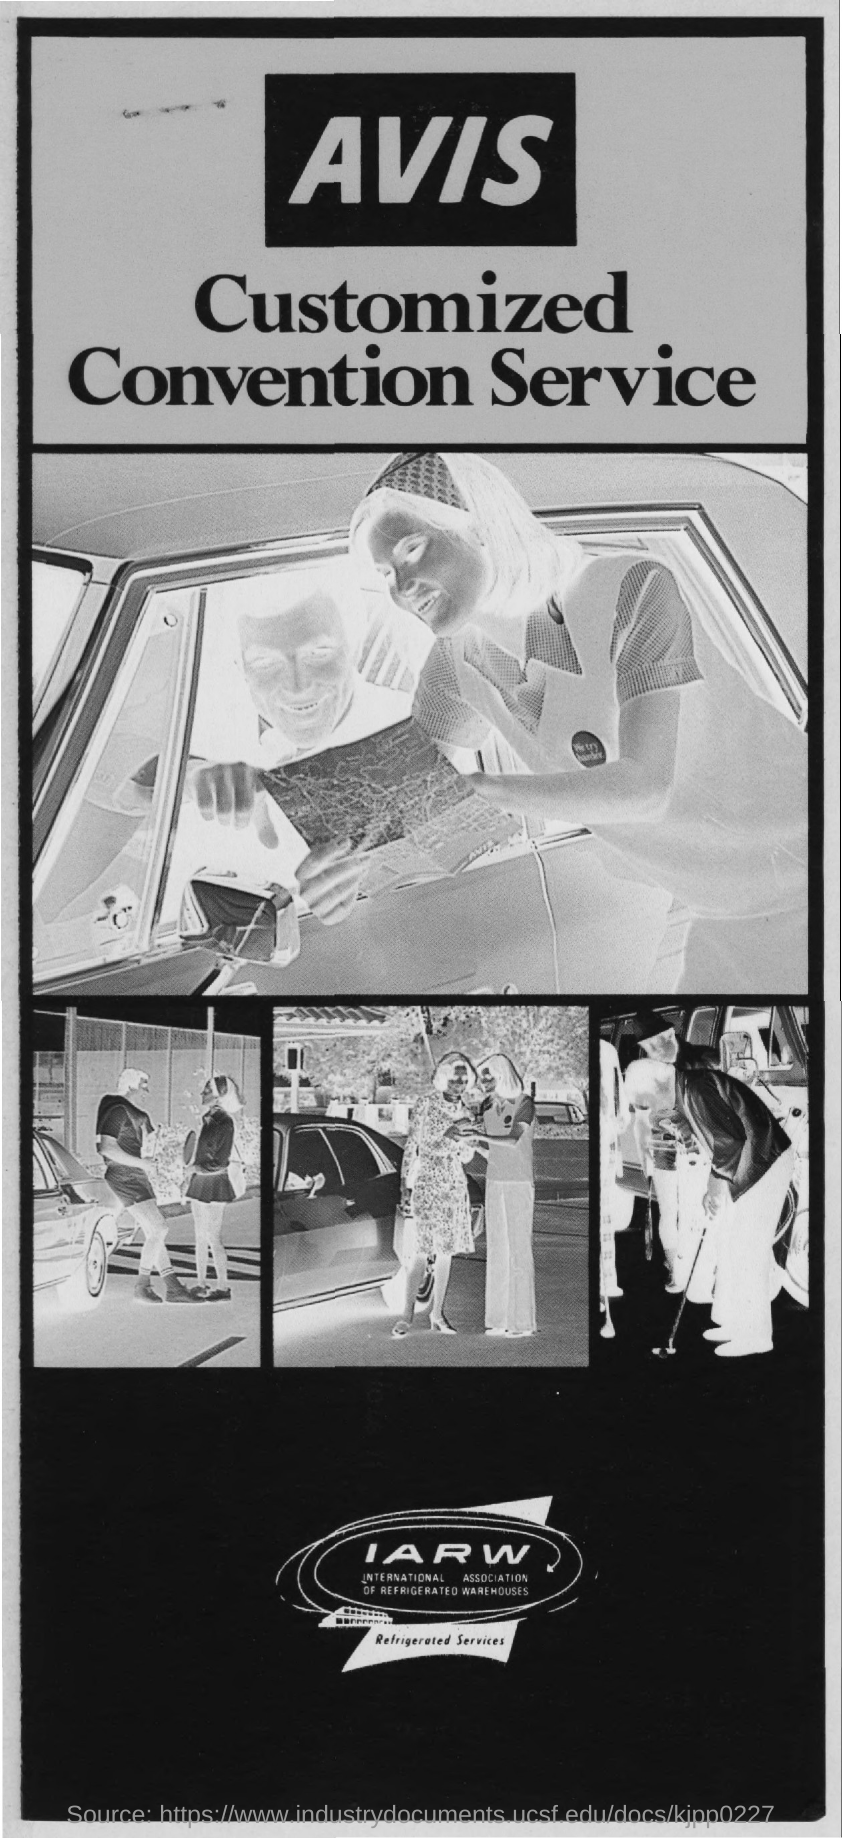Highlight a few significant elements in this photo. International Association of Refrigerated Warehouses, commonly referred to as IARW, is a worldwide organization dedicated to promoting the interests and advancing the welfare of the refrigerated warehouse industry. Refrigerated services refer to the transport and storage of temperature-sensitive goods, such as perishable food items, pharmaceuticals, and chemicals, at a controlled temperature range to ensure their quality and safety. 